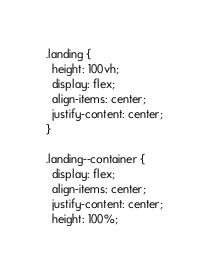Convert code to text. <code><loc_0><loc_0><loc_500><loc_500><_CSS_>.landing {
  height: 100vh;
  display: flex;
  align-items: center;
  justify-content: center;
}

.landing--container {
  display: flex;
  align-items: center;
  justify-content: center;
  height: 100%;</code> 